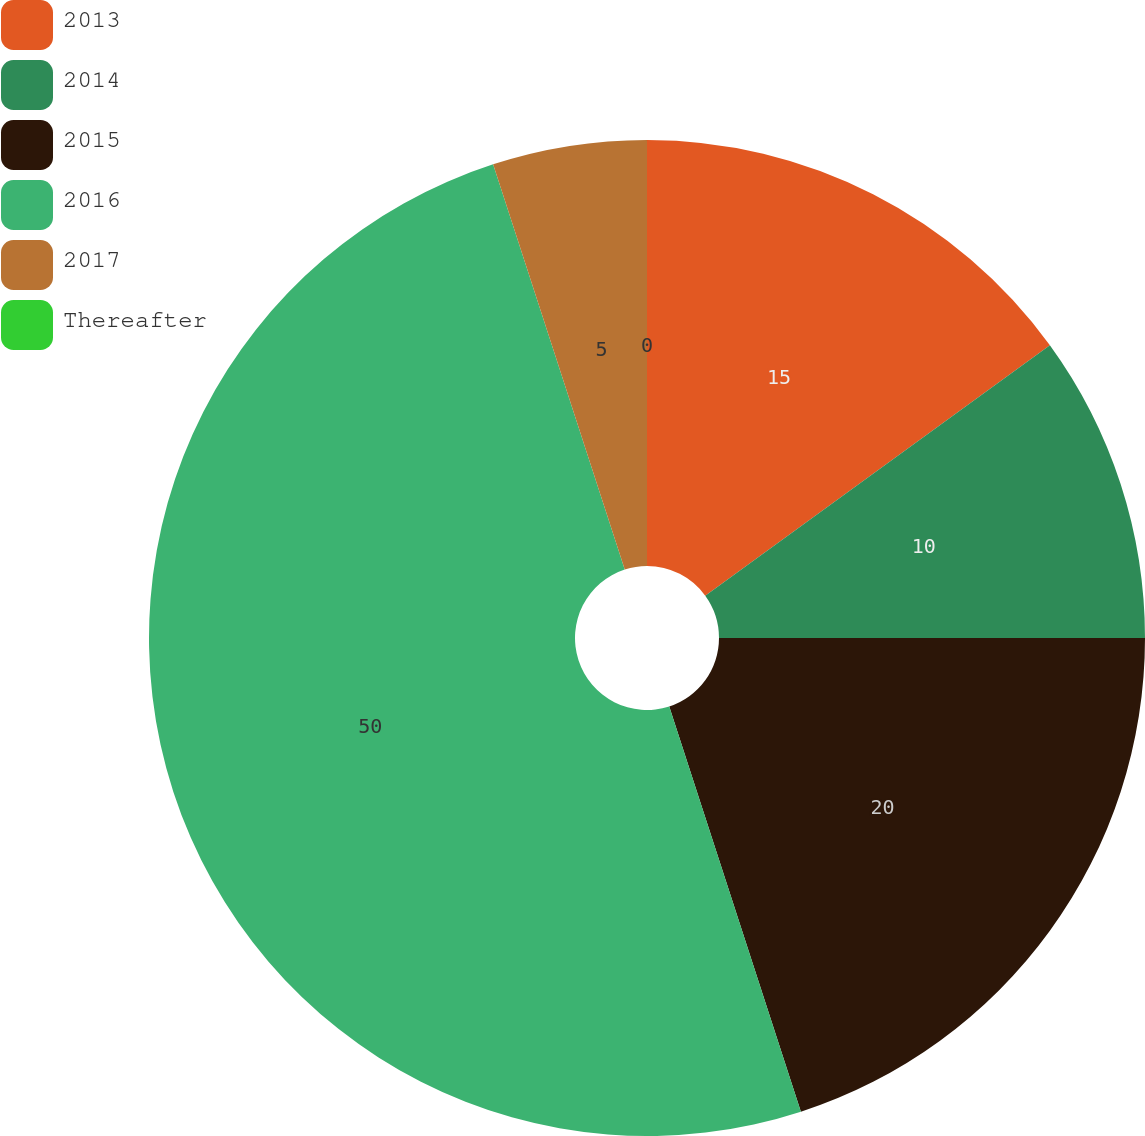<chart> <loc_0><loc_0><loc_500><loc_500><pie_chart><fcel>2013<fcel>2014<fcel>2015<fcel>2016<fcel>2017<fcel>Thereafter<nl><fcel>15.0%<fcel>10.0%<fcel>20.0%<fcel>50.0%<fcel>5.0%<fcel>0.0%<nl></chart> 